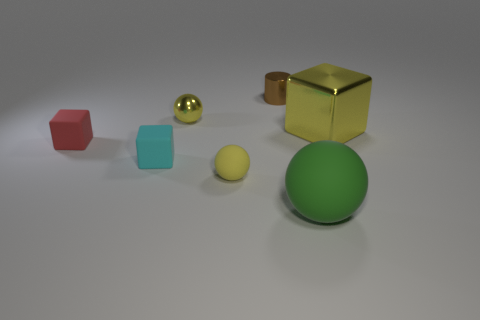There is a tiny object that is the same color as the shiny sphere; what is its shape?
Offer a very short reply. Sphere. The metallic sphere that is the same color as the metallic cube is what size?
Your response must be concise. Small. Are there more large spheres on the right side of the yellow shiny ball than metal objects that are right of the big green matte ball?
Offer a very short reply. No. Do the large block and the matte ball that is on the left side of the green thing have the same color?
Make the answer very short. Yes. There is a yellow object that is the same size as the green matte sphere; what material is it?
Your response must be concise. Metal. How many objects are either yellow rubber balls or blocks that are left of the shiny cylinder?
Your answer should be compact. 3. There is a green thing; is its size the same as the cube right of the tiny cyan rubber cube?
Your answer should be very brief. Yes. What number of spheres are either small things or large green things?
Your answer should be compact. 3. How many blocks are both to the left of the yellow metallic cube and right of the tiny brown metallic object?
Ensure brevity in your answer.  0. What number of other objects are the same color as the big metallic object?
Your answer should be compact. 2. 